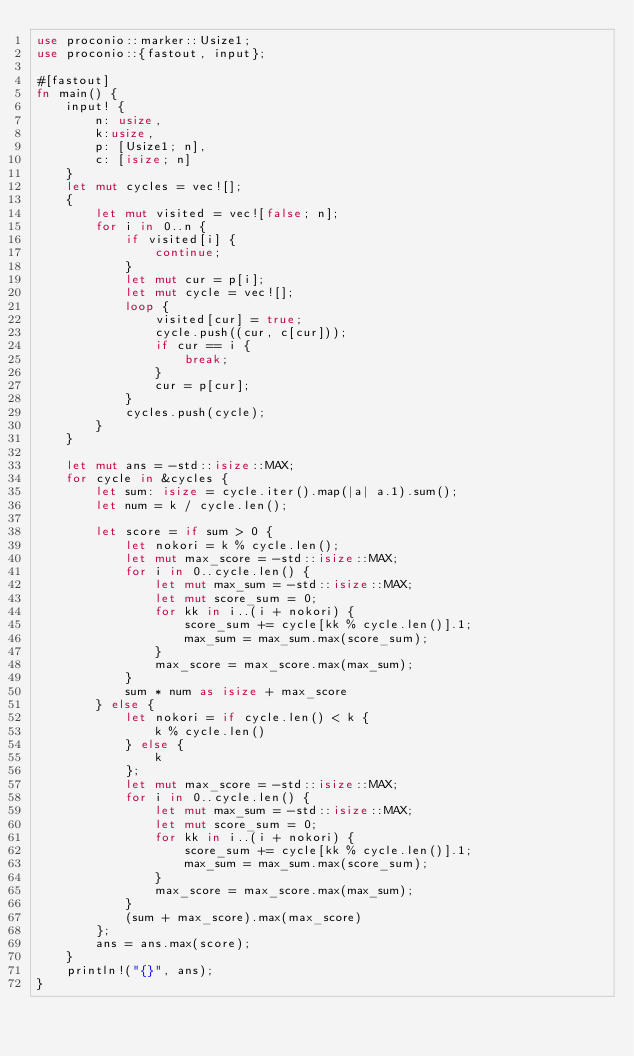Convert code to text. <code><loc_0><loc_0><loc_500><loc_500><_Rust_>use proconio::marker::Usize1;
use proconio::{fastout, input};

#[fastout]
fn main() {
    input! {
        n: usize,
        k:usize,
        p: [Usize1; n],
        c: [isize; n]
    }
    let mut cycles = vec![];
    {
        let mut visited = vec![false; n];
        for i in 0..n {
            if visited[i] {
                continue;
            }
            let mut cur = p[i];
            let mut cycle = vec![];
            loop {
                visited[cur] = true;
                cycle.push((cur, c[cur]));
                if cur == i {
                    break;
                }
                cur = p[cur];
            }
            cycles.push(cycle);
        }
    }

    let mut ans = -std::isize::MAX;
    for cycle in &cycles {
        let sum: isize = cycle.iter().map(|a| a.1).sum();
        let num = k / cycle.len();

        let score = if sum > 0 {
            let nokori = k % cycle.len();
            let mut max_score = -std::isize::MAX;
            for i in 0..cycle.len() {
                let mut max_sum = -std::isize::MAX;
                let mut score_sum = 0;
                for kk in i..(i + nokori) {
                    score_sum += cycle[kk % cycle.len()].1;
                    max_sum = max_sum.max(score_sum);
                }
                max_score = max_score.max(max_sum);
            }
            sum * num as isize + max_score
        } else {
            let nokori = if cycle.len() < k {
                k % cycle.len()
            } else {
                k
            };
            let mut max_score = -std::isize::MAX;
            for i in 0..cycle.len() {
                let mut max_sum = -std::isize::MAX;
                let mut score_sum = 0;
                for kk in i..(i + nokori) {
                    score_sum += cycle[kk % cycle.len()].1;
                    max_sum = max_sum.max(score_sum);
                }
                max_score = max_score.max(max_sum);
            }
            (sum + max_score).max(max_score)
        };
        ans = ans.max(score);
    }
    println!("{}", ans);
}
</code> 